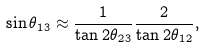<formula> <loc_0><loc_0><loc_500><loc_500>\sin \theta _ { 1 3 } \approx \frac { 1 } { \tan 2 \theta _ { 2 3 } } \frac { 2 } { \tan 2 \theta _ { 1 2 } } ,</formula> 